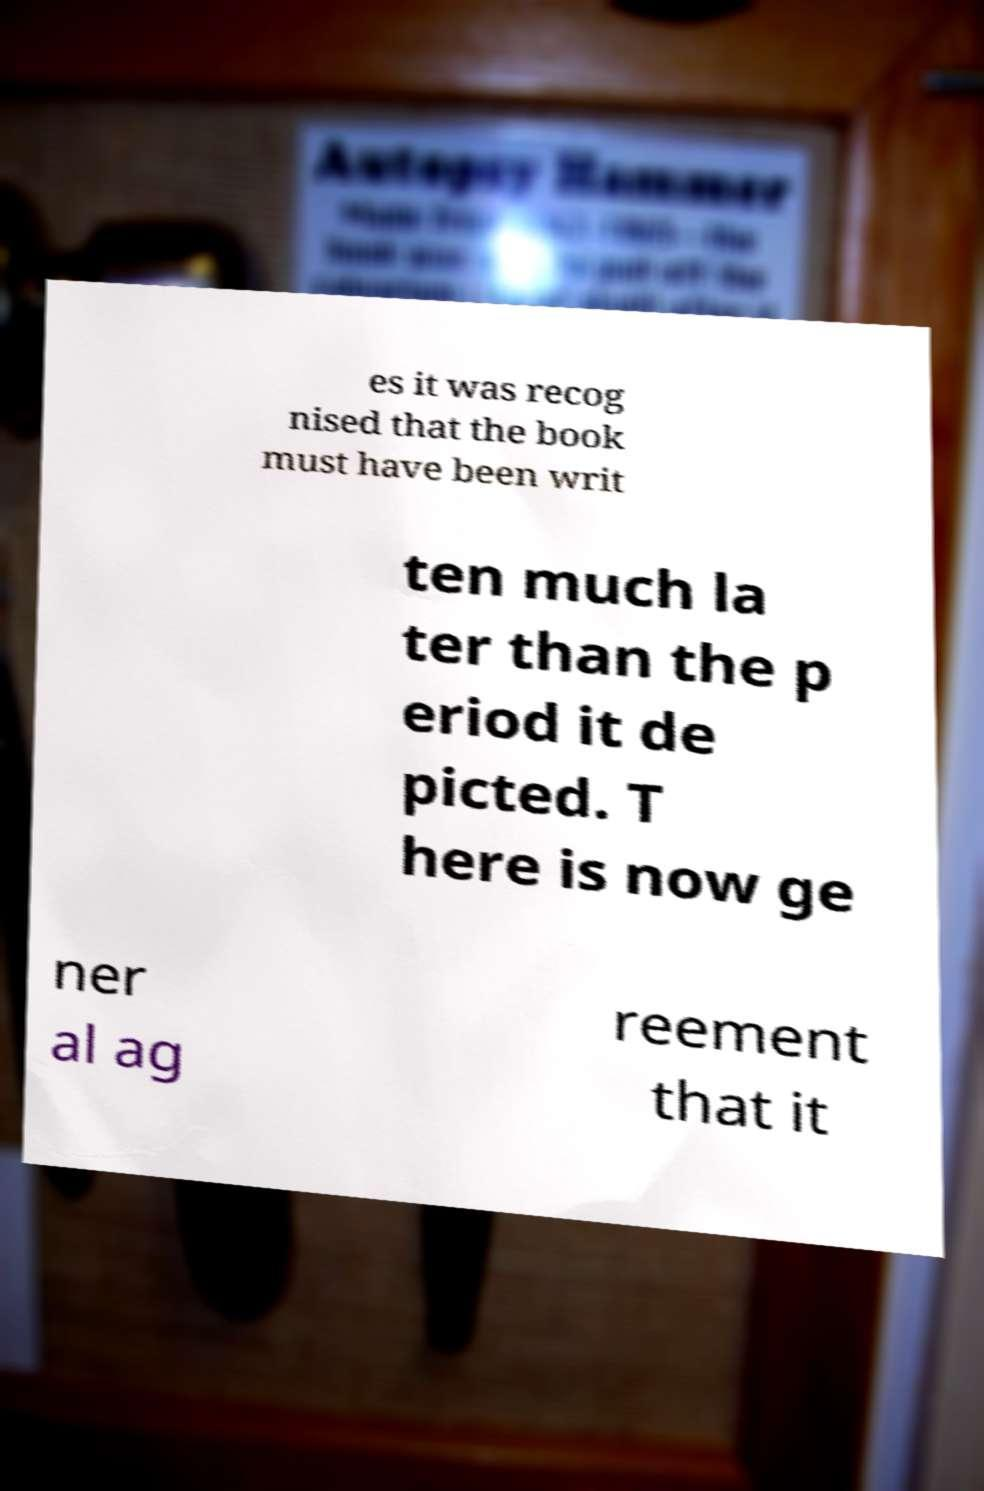Please read and relay the text visible in this image. What does it say? es it was recog nised that the book must have been writ ten much la ter than the p eriod it de picted. T here is now ge ner al ag reement that it 